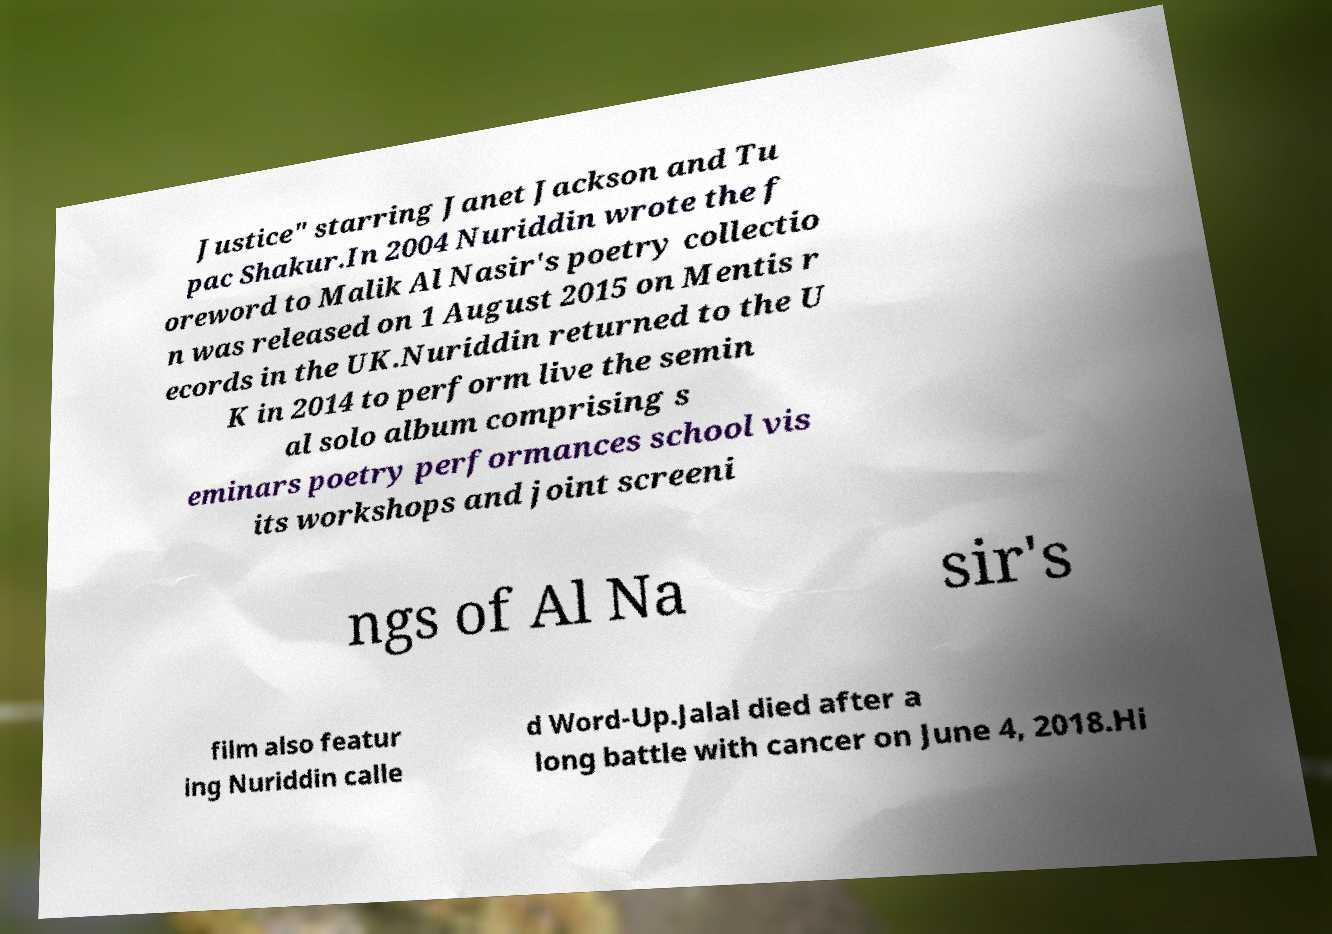There's text embedded in this image that I need extracted. Can you transcribe it verbatim? Justice" starring Janet Jackson and Tu pac Shakur.In 2004 Nuriddin wrote the f oreword to Malik Al Nasir's poetry collectio n was released on 1 August 2015 on Mentis r ecords in the UK.Nuriddin returned to the U K in 2014 to perform live the semin al solo album comprising s eminars poetry performances school vis its workshops and joint screeni ngs of Al Na sir's film also featur ing Nuriddin calle d Word-Up.Jalal died after a long battle with cancer on June 4, 2018.Hi 